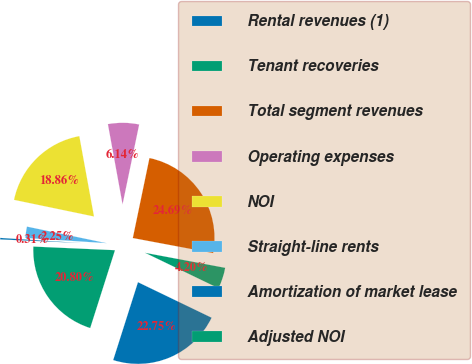Convert chart to OTSL. <chart><loc_0><loc_0><loc_500><loc_500><pie_chart><fcel>Rental revenues (1)<fcel>Tenant recoveries<fcel>Total segment revenues<fcel>Operating expenses<fcel>NOI<fcel>Straight-line rents<fcel>Amortization of market lease<fcel>Adjusted NOI<nl><fcel>22.75%<fcel>4.2%<fcel>24.69%<fcel>6.14%<fcel>18.86%<fcel>2.25%<fcel>0.31%<fcel>20.8%<nl></chart> 